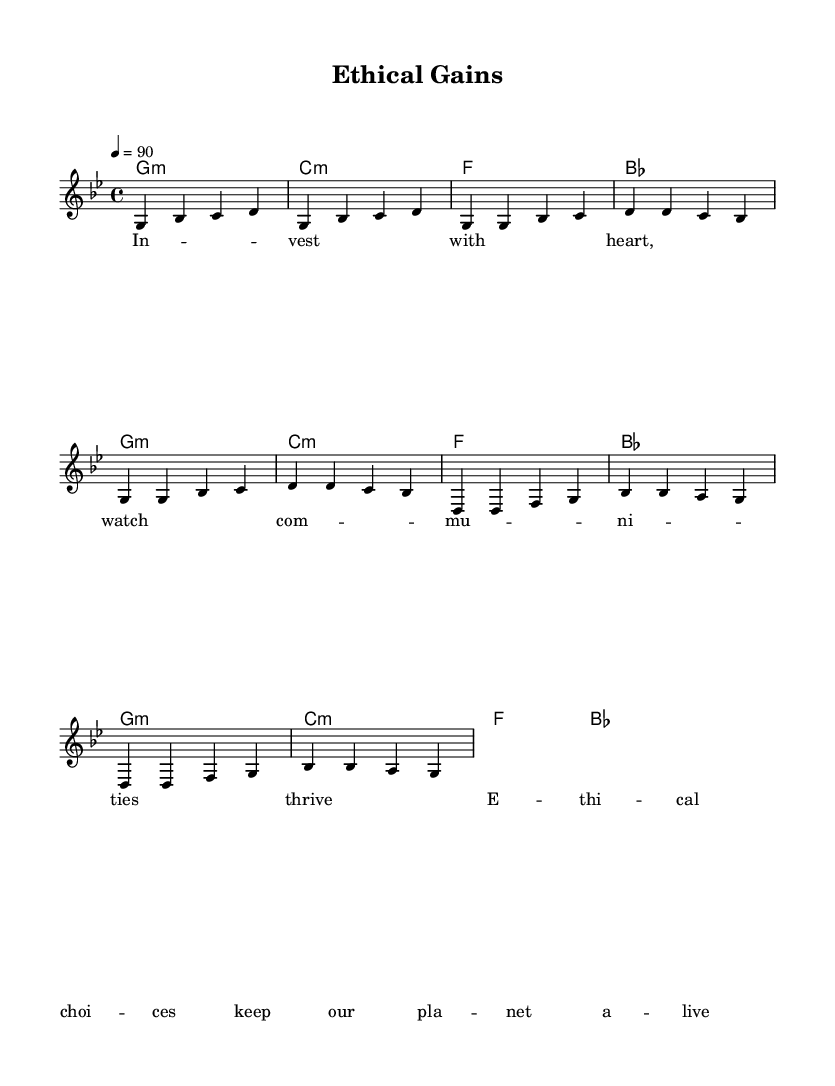What is the key signature of this music? The key signature is indicated by the absence of sharps or flats in the music sheet, confirming that the piece is in G minor which has two flats.
Answer: G minor What is the time signature of the composition? The time signature of the music is found at the beginning of the sheet music, which indicates that there are four beats per measure.
Answer: 4/4 What is the tempo of the piece? The tempo marking shows that the piece should be played at a speed of 90 beats per minute, represented by the notation "4 = 90" above the staff.
Answer: 90 How many measures are in the chorus section? By counting the distinct groupings of musical notes that make up the chorus segment, we see there are four separate measures.
Answer: 4 What is the overall theme of the lyrics? The lyrics focus on the importance of making ethical investments and their positive effects on communities and the environment, acting as a motivational message.
Answer: Ethical impact How does the chord progression in the verse compare to the chorus? Observing both sections, they both use the same chord progression (G minor, C minor, F, B flat), which signifies a shared musical structure throughout the piece.
Answer: Same progression What is the emotional tone of the piece suggested by the lyrics and music? The lyrics depict a hopeful and uplifting message, while the minor key and upbeat tempo combine to create an inspirational and positive emotional tone.
Answer: Inspirational 